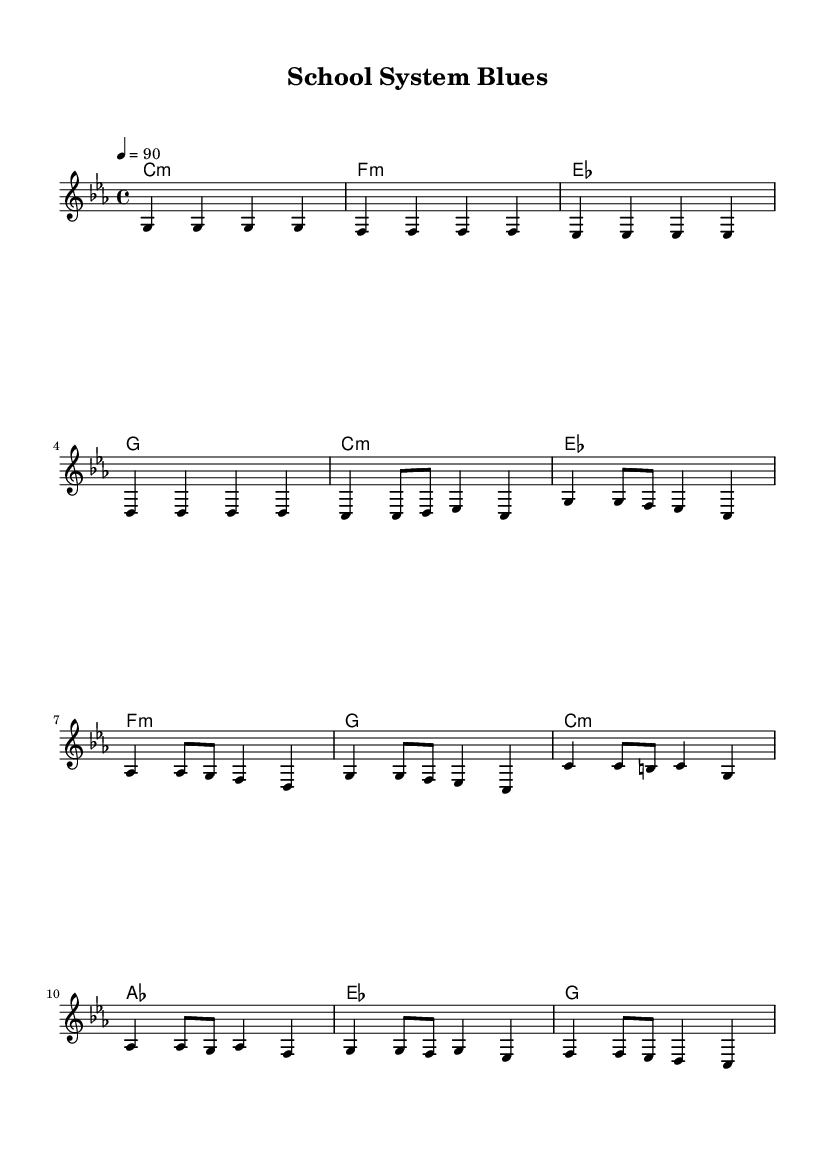What is the key signature of this music? The key signature is C minor, which contains three flat notes: B flat, E flat, and A flat. This is identifiable by the key signature indicated at the beginning of the staff.
Answer: C minor What is the time signature of this music? The time signature is 4/4, meaning there are four beats in each measure, and the quarter note gets one beat. This is shown at the beginning of the musical notation.
Answer: 4/4 What is the tempo marking for this piece? The tempo marking states that the piece should be played at a speed of 90 beats per minute. This tempo indication is noted as "4 = 90" in the header.
Answer: 90 How many measures are in the verse section? The verse section consists of four measures. By counting the separated measures within the section labeled "Verse," we can determine the total.
Answer: 4 Which chord is associated with the chorus? The chorus prominently features an A flat major chord, as indicated in the chord progression for the chorus section. The A flat chord is represented in the chord changes below the melody.
Answer: A flat Is there a repeated motif in the melody? Yes, the motif of the notes G and F appears multiple times in both the verse and chorus sections, showcasing a recurring theme. This repetition can be observed in several places throughout the melody.
Answer: Yes What message does the song title suggest? The song title "School System Blues" implies a critique of the education system, particularly regarding social issues such as inequality and privilege. The title hints at themes of frustration and concern towards educational disparities.
Answer: Critique of the education system 